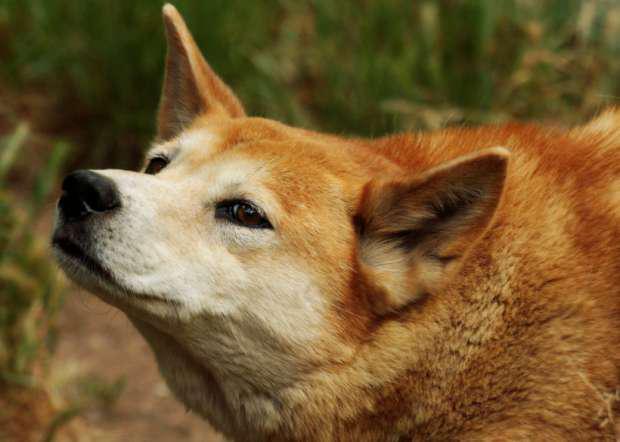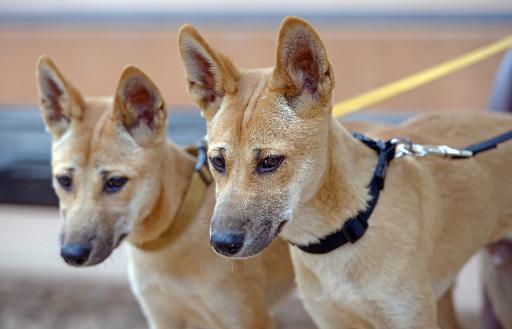The first image is the image on the left, the second image is the image on the right. For the images shown, is this caption "One of the images contains at least two dogs." true? Answer yes or no. Yes. 